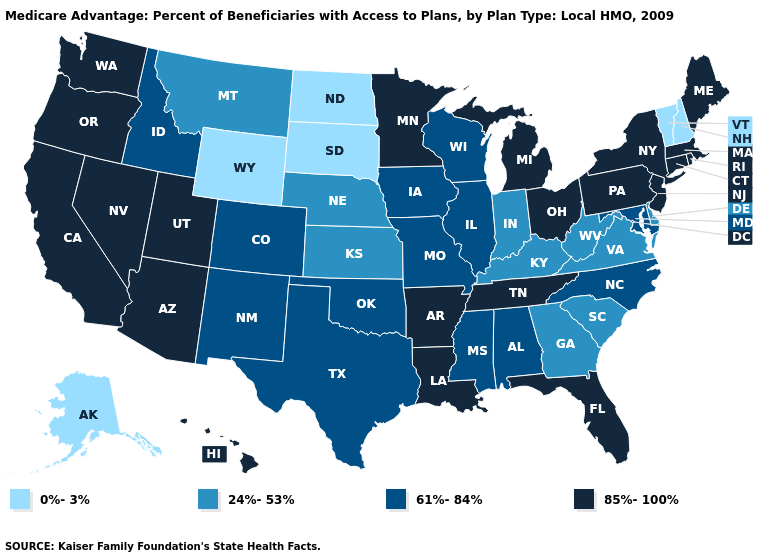What is the value of New Jersey?
Keep it brief. 85%-100%. Name the states that have a value in the range 85%-100%?
Give a very brief answer. Arkansas, Arizona, California, Connecticut, Florida, Hawaii, Louisiana, Massachusetts, Maine, Michigan, Minnesota, New Jersey, Nevada, New York, Ohio, Oregon, Pennsylvania, Rhode Island, Tennessee, Utah, Washington. What is the value of Washington?
Answer briefly. 85%-100%. Does Connecticut have a higher value than Alaska?
Be succinct. Yes. Does Pennsylvania have a higher value than South Carolina?
Give a very brief answer. Yes. What is the value of Connecticut?
Short answer required. 85%-100%. What is the lowest value in the West?
Be succinct. 0%-3%. Does Texas have the lowest value in the South?
Give a very brief answer. No. Is the legend a continuous bar?
Concise answer only. No. What is the value of Ohio?
Concise answer only. 85%-100%. What is the value of Utah?
Be succinct. 85%-100%. Among the states that border New Hampshire , does Vermont have the highest value?
Write a very short answer. No. Does New Hampshire have the highest value in the USA?
Keep it brief. No. Which states hav the highest value in the Northeast?
Give a very brief answer. Connecticut, Massachusetts, Maine, New Jersey, New York, Pennsylvania, Rhode Island. 